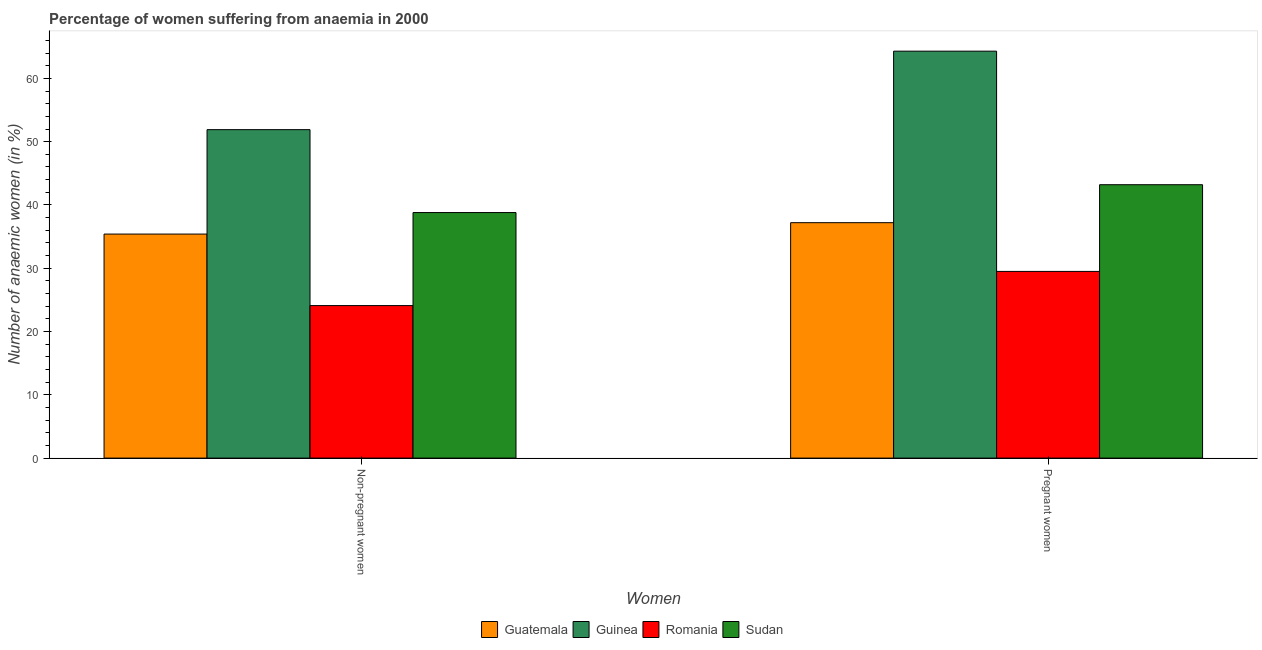How many different coloured bars are there?
Keep it short and to the point. 4. Are the number of bars per tick equal to the number of legend labels?
Offer a very short reply. Yes. Are the number of bars on each tick of the X-axis equal?
Offer a terse response. Yes. What is the label of the 2nd group of bars from the left?
Offer a very short reply. Pregnant women. What is the percentage of pregnant anaemic women in Sudan?
Provide a short and direct response. 43.2. Across all countries, what is the maximum percentage of pregnant anaemic women?
Make the answer very short. 64.3. Across all countries, what is the minimum percentage of non-pregnant anaemic women?
Your answer should be very brief. 24.1. In which country was the percentage of pregnant anaemic women maximum?
Make the answer very short. Guinea. In which country was the percentage of non-pregnant anaemic women minimum?
Provide a short and direct response. Romania. What is the total percentage of non-pregnant anaemic women in the graph?
Provide a short and direct response. 150.2. What is the difference between the percentage of non-pregnant anaemic women in Romania and that in Guinea?
Keep it short and to the point. -27.8. What is the difference between the percentage of pregnant anaemic women in Guatemala and the percentage of non-pregnant anaemic women in Romania?
Give a very brief answer. 13.1. What is the average percentage of non-pregnant anaemic women per country?
Make the answer very short. 37.55. What is the difference between the percentage of non-pregnant anaemic women and percentage of pregnant anaemic women in Romania?
Offer a very short reply. -5.4. In how many countries, is the percentage of pregnant anaemic women greater than 34 %?
Ensure brevity in your answer.  3. What is the ratio of the percentage of pregnant anaemic women in Romania to that in Guatemala?
Give a very brief answer. 0.79. What does the 3rd bar from the left in Non-pregnant women represents?
Offer a terse response. Romania. What does the 2nd bar from the right in Non-pregnant women represents?
Ensure brevity in your answer.  Romania. Are all the bars in the graph horizontal?
Ensure brevity in your answer.  No. How many countries are there in the graph?
Provide a short and direct response. 4. What is the difference between two consecutive major ticks on the Y-axis?
Ensure brevity in your answer.  10. How many legend labels are there?
Keep it short and to the point. 4. How are the legend labels stacked?
Give a very brief answer. Horizontal. What is the title of the graph?
Provide a short and direct response. Percentage of women suffering from anaemia in 2000. What is the label or title of the X-axis?
Your answer should be very brief. Women. What is the label or title of the Y-axis?
Make the answer very short. Number of anaemic women (in %). What is the Number of anaemic women (in %) in Guatemala in Non-pregnant women?
Keep it short and to the point. 35.4. What is the Number of anaemic women (in %) of Guinea in Non-pregnant women?
Make the answer very short. 51.9. What is the Number of anaemic women (in %) of Romania in Non-pregnant women?
Your answer should be very brief. 24.1. What is the Number of anaemic women (in %) of Sudan in Non-pregnant women?
Your answer should be very brief. 38.8. What is the Number of anaemic women (in %) in Guatemala in Pregnant women?
Make the answer very short. 37.2. What is the Number of anaemic women (in %) of Guinea in Pregnant women?
Offer a terse response. 64.3. What is the Number of anaemic women (in %) in Romania in Pregnant women?
Give a very brief answer. 29.5. What is the Number of anaemic women (in %) in Sudan in Pregnant women?
Provide a short and direct response. 43.2. Across all Women, what is the maximum Number of anaemic women (in %) of Guatemala?
Provide a succinct answer. 37.2. Across all Women, what is the maximum Number of anaemic women (in %) of Guinea?
Your answer should be compact. 64.3. Across all Women, what is the maximum Number of anaemic women (in %) in Romania?
Ensure brevity in your answer.  29.5. Across all Women, what is the maximum Number of anaemic women (in %) of Sudan?
Offer a very short reply. 43.2. Across all Women, what is the minimum Number of anaemic women (in %) of Guatemala?
Keep it short and to the point. 35.4. Across all Women, what is the minimum Number of anaemic women (in %) in Guinea?
Provide a succinct answer. 51.9. Across all Women, what is the minimum Number of anaemic women (in %) of Romania?
Your answer should be compact. 24.1. Across all Women, what is the minimum Number of anaemic women (in %) of Sudan?
Provide a short and direct response. 38.8. What is the total Number of anaemic women (in %) in Guatemala in the graph?
Offer a very short reply. 72.6. What is the total Number of anaemic women (in %) of Guinea in the graph?
Provide a succinct answer. 116.2. What is the total Number of anaemic women (in %) of Romania in the graph?
Give a very brief answer. 53.6. What is the difference between the Number of anaemic women (in %) of Sudan in Non-pregnant women and that in Pregnant women?
Provide a short and direct response. -4.4. What is the difference between the Number of anaemic women (in %) of Guatemala in Non-pregnant women and the Number of anaemic women (in %) of Guinea in Pregnant women?
Offer a terse response. -28.9. What is the difference between the Number of anaemic women (in %) of Guatemala in Non-pregnant women and the Number of anaemic women (in %) of Romania in Pregnant women?
Offer a very short reply. 5.9. What is the difference between the Number of anaemic women (in %) of Guatemala in Non-pregnant women and the Number of anaemic women (in %) of Sudan in Pregnant women?
Provide a succinct answer. -7.8. What is the difference between the Number of anaemic women (in %) of Guinea in Non-pregnant women and the Number of anaemic women (in %) of Romania in Pregnant women?
Your answer should be compact. 22.4. What is the difference between the Number of anaemic women (in %) in Guinea in Non-pregnant women and the Number of anaemic women (in %) in Sudan in Pregnant women?
Offer a very short reply. 8.7. What is the difference between the Number of anaemic women (in %) in Romania in Non-pregnant women and the Number of anaemic women (in %) in Sudan in Pregnant women?
Your answer should be very brief. -19.1. What is the average Number of anaemic women (in %) in Guatemala per Women?
Provide a succinct answer. 36.3. What is the average Number of anaemic women (in %) of Guinea per Women?
Ensure brevity in your answer.  58.1. What is the average Number of anaemic women (in %) of Romania per Women?
Keep it short and to the point. 26.8. What is the difference between the Number of anaemic women (in %) of Guatemala and Number of anaemic women (in %) of Guinea in Non-pregnant women?
Make the answer very short. -16.5. What is the difference between the Number of anaemic women (in %) in Guatemala and Number of anaemic women (in %) in Sudan in Non-pregnant women?
Make the answer very short. -3.4. What is the difference between the Number of anaemic women (in %) of Guinea and Number of anaemic women (in %) of Romania in Non-pregnant women?
Make the answer very short. 27.8. What is the difference between the Number of anaemic women (in %) of Romania and Number of anaemic women (in %) of Sudan in Non-pregnant women?
Provide a succinct answer. -14.7. What is the difference between the Number of anaemic women (in %) of Guatemala and Number of anaemic women (in %) of Guinea in Pregnant women?
Make the answer very short. -27.1. What is the difference between the Number of anaemic women (in %) of Guatemala and Number of anaemic women (in %) of Romania in Pregnant women?
Ensure brevity in your answer.  7.7. What is the difference between the Number of anaemic women (in %) of Guatemala and Number of anaemic women (in %) of Sudan in Pregnant women?
Your answer should be compact. -6. What is the difference between the Number of anaemic women (in %) in Guinea and Number of anaemic women (in %) in Romania in Pregnant women?
Your answer should be very brief. 34.8. What is the difference between the Number of anaemic women (in %) in Guinea and Number of anaemic women (in %) in Sudan in Pregnant women?
Ensure brevity in your answer.  21.1. What is the difference between the Number of anaemic women (in %) in Romania and Number of anaemic women (in %) in Sudan in Pregnant women?
Your response must be concise. -13.7. What is the ratio of the Number of anaemic women (in %) of Guatemala in Non-pregnant women to that in Pregnant women?
Provide a short and direct response. 0.95. What is the ratio of the Number of anaemic women (in %) in Guinea in Non-pregnant women to that in Pregnant women?
Ensure brevity in your answer.  0.81. What is the ratio of the Number of anaemic women (in %) in Romania in Non-pregnant women to that in Pregnant women?
Your answer should be very brief. 0.82. What is the ratio of the Number of anaemic women (in %) in Sudan in Non-pregnant women to that in Pregnant women?
Keep it short and to the point. 0.9. What is the difference between the highest and the second highest Number of anaemic women (in %) of Guatemala?
Make the answer very short. 1.8. What is the difference between the highest and the second highest Number of anaemic women (in %) of Sudan?
Keep it short and to the point. 4.4. What is the difference between the highest and the lowest Number of anaemic women (in %) of Guatemala?
Keep it short and to the point. 1.8. 